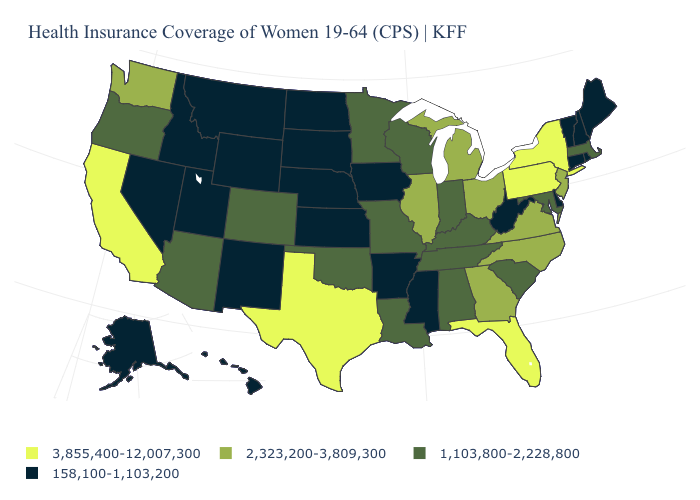Name the states that have a value in the range 158,100-1,103,200?
Concise answer only. Alaska, Arkansas, Connecticut, Delaware, Hawaii, Idaho, Iowa, Kansas, Maine, Mississippi, Montana, Nebraska, Nevada, New Hampshire, New Mexico, North Dakota, Rhode Island, South Dakota, Utah, Vermont, West Virginia, Wyoming. Does the map have missing data?
Write a very short answer. No. Which states hav the highest value in the South?
Keep it brief. Florida, Texas. How many symbols are there in the legend?
Keep it brief. 4. What is the value of Ohio?
Write a very short answer. 2,323,200-3,809,300. Name the states that have a value in the range 158,100-1,103,200?
Keep it brief. Alaska, Arkansas, Connecticut, Delaware, Hawaii, Idaho, Iowa, Kansas, Maine, Mississippi, Montana, Nebraska, Nevada, New Hampshire, New Mexico, North Dakota, Rhode Island, South Dakota, Utah, Vermont, West Virginia, Wyoming. Among the states that border Utah , does Colorado have the lowest value?
Short answer required. No. Which states have the lowest value in the South?
Give a very brief answer. Arkansas, Delaware, Mississippi, West Virginia. What is the value of South Dakota?
Quick response, please. 158,100-1,103,200. Name the states that have a value in the range 3,855,400-12,007,300?
Write a very short answer. California, Florida, New York, Pennsylvania, Texas. Does the map have missing data?
Short answer required. No. What is the value of New Jersey?
Keep it brief. 2,323,200-3,809,300. Does the map have missing data?
Concise answer only. No. What is the value of Minnesota?
Quick response, please. 1,103,800-2,228,800. Does Washington have the highest value in the West?
Write a very short answer. No. 